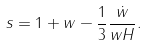<formula> <loc_0><loc_0><loc_500><loc_500>s = 1 + w - \frac { 1 } { 3 } \frac { \dot { w } } { w H } .</formula> 